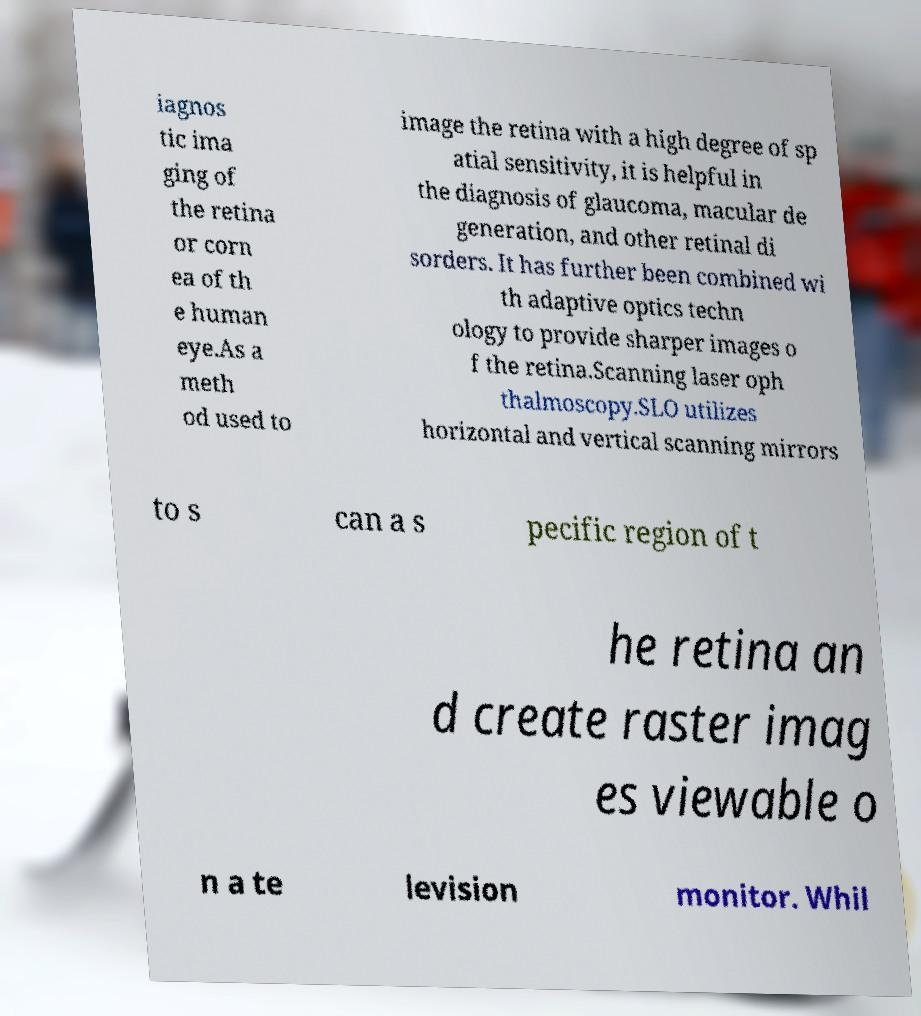Could you extract and type out the text from this image? iagnos tic ima ging of the retina or corn ea of th e human eye.As a meth od used to image the retina with a high degree of sp atial sensitivity, it is helpful in the diagnosis of glaucoma, macular de generation, and other retinal di sorders. It has further been combined wi th adaptive optics techn ology to provide sharper images o f the retina.Scanning laser oph thalmoscopy.SLO utilizes horizontal and vertical scanning mirrors to s can a s pecific region of t he retina an d create raster imag es viewable o n a te levision monitor. Whil 